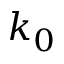Convert formula to latex. <formula><loc_0><loc_0><loc_500><loc_500>k _ { 0 }</formula> 